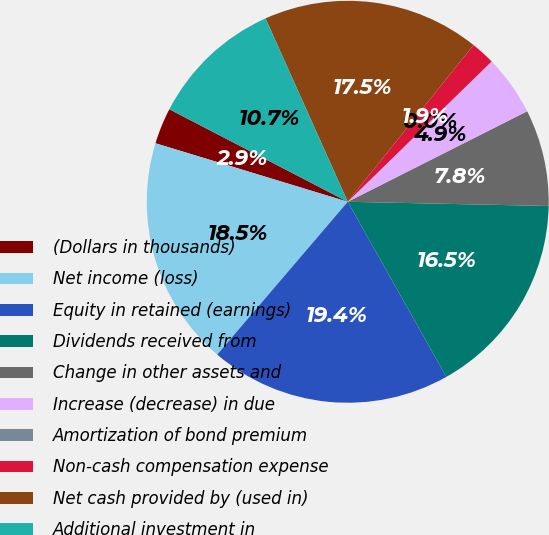Convert chart. <chart><loc_0><loc_0><loc_500><loc_500><pie_chart><fcel>(Dollars in thousands)<fcel>Net income (loss)<fcel>Equity in retained (earnings)<fcel>Dividends received from<fcel>Change in other assets and<fcel>Increase (decrease) in due<fcel>Amortization of bond premium<fcel>Non-cash compensation expense<fcel>Net cash provided by (used in)<fcel>Additional investment in<nl><fcel>2.91%<fcel>18.45%<fcel>19.42%<fcel>16.5%<fcel>7.77%<fcel>4.86%<fcel>0.0%<fcel>1.94%<fcel>17.47%<fcel>10.68%<nl></chart> 